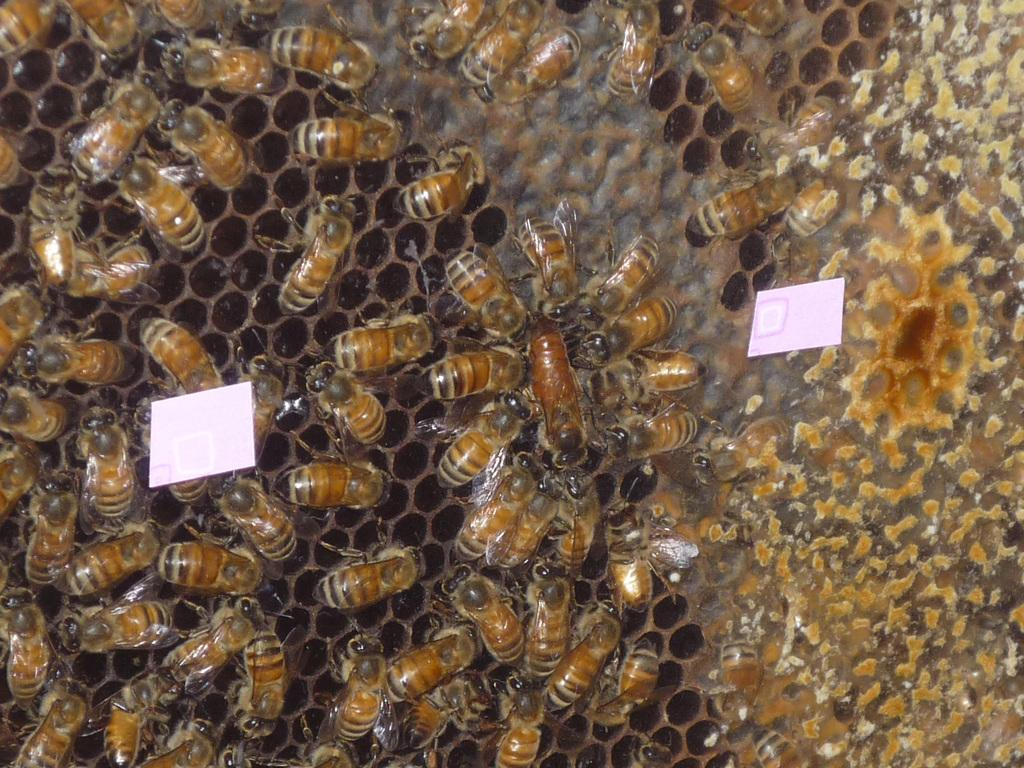What type of insects are present in the image? There are honey bees in the image. Where are the honey bees located? The honey bees are on a honeycomb. What type of plastic material can be seen in the image? There is no plastic material present in the image; it features honey bees on a honeycomb. How do the honey bees move in the image? The honey bees' motion cannot be determined from the image alone, as it is a still photograph. 